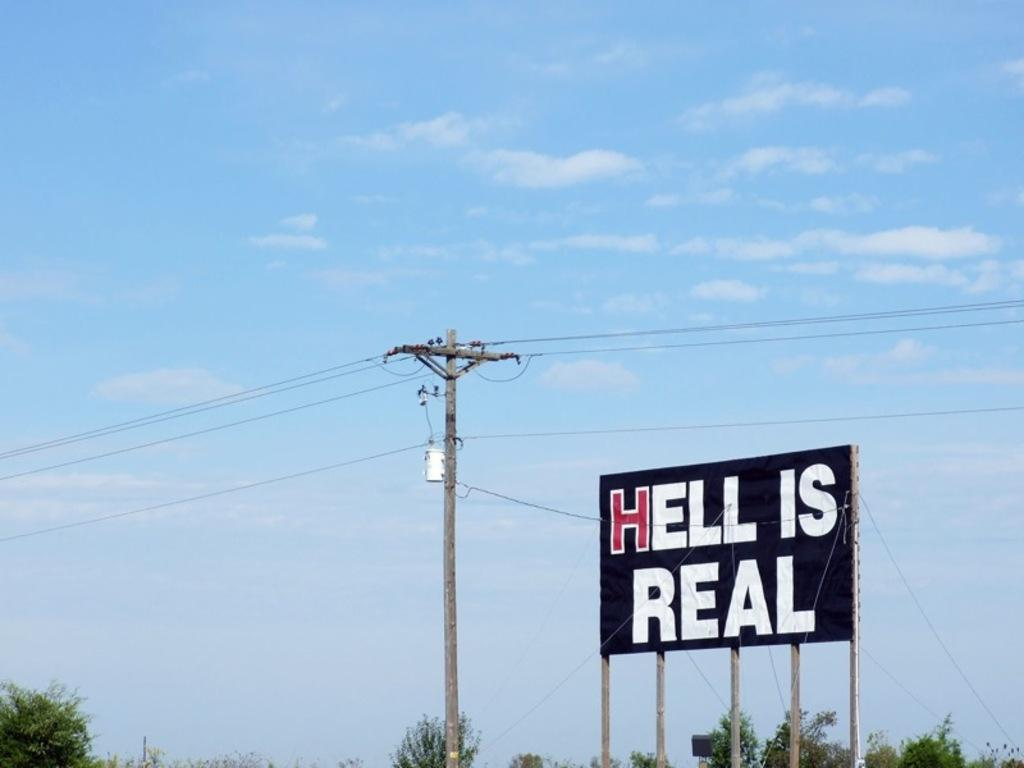<image>
Share a concise interpretation of the image provided. a Hell is Real sign that is above the ground 